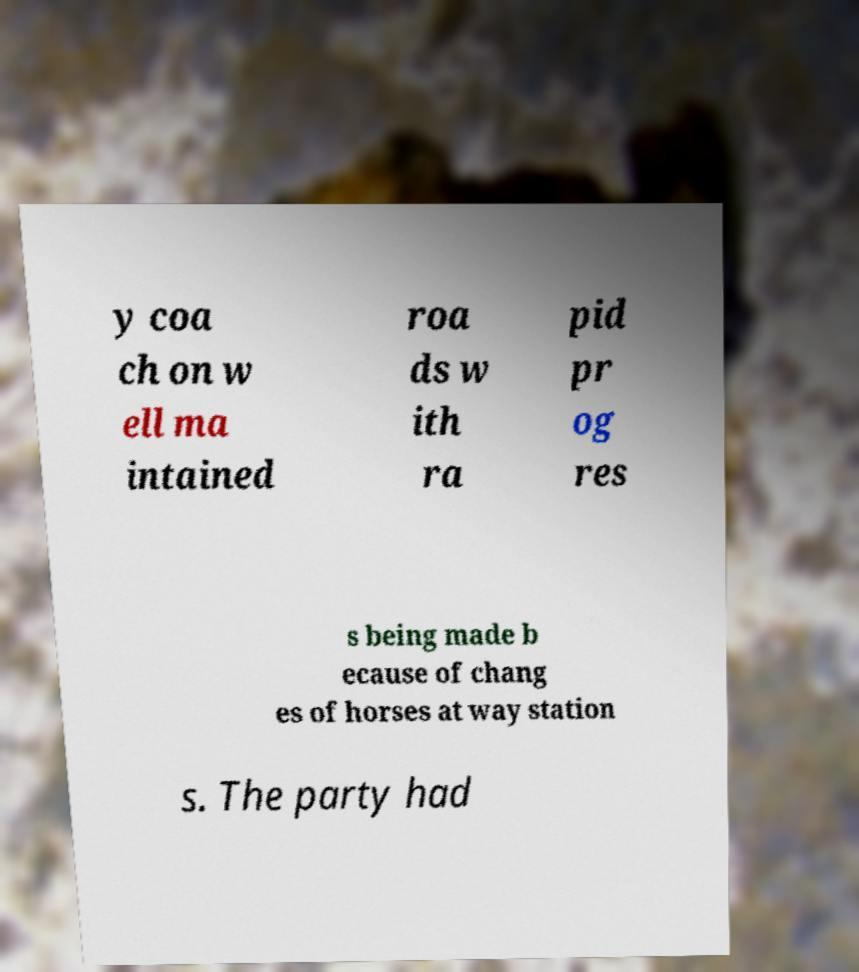There's text embedded in this image that I need extracted. Can you transcribe it verbatim? y coa ch on w ell ma intained roa ds w ith ra pid pr og res s being made b ecause of chang es of horses at way station s. The party had 